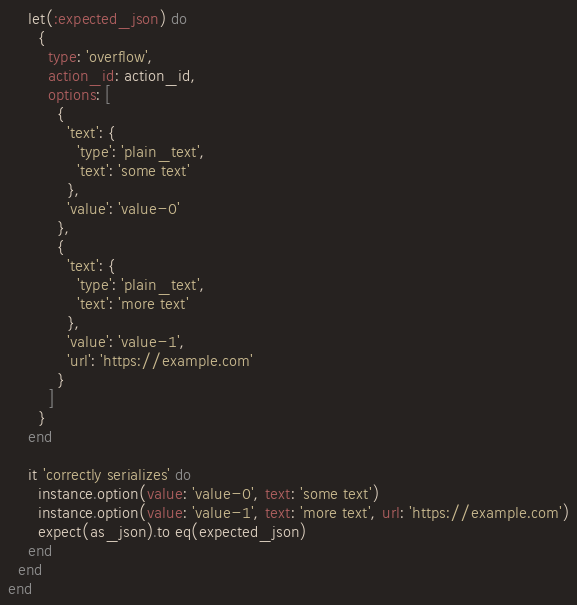<code> <loc_0><loc_0><loc_500><loc_500><_Ruby_>    let(:expected_json) do
      {
        type: 'overflow',
        action_id: action_id,
        options: [
          {
            'text': {
              'type': 'plain_text',
              'text': 'some text'
            },
            'value': 'value-0'
          },
          {
            'text': {
              'type': 'plain_text',
              'text': 'more text'
            },
            'value': 'value-1',
            'url': 'https://example.com'
          }
        ]
      }
    end

    it 'correctly serializes' do
      instance.option(value: 'value-0', text: 'some text')
      instance.option(value: 'value-1', text: 'more text', url: 'https://example.com')
      expect(as_json).to eq(expected_json)
    end
  end
end
</code> 